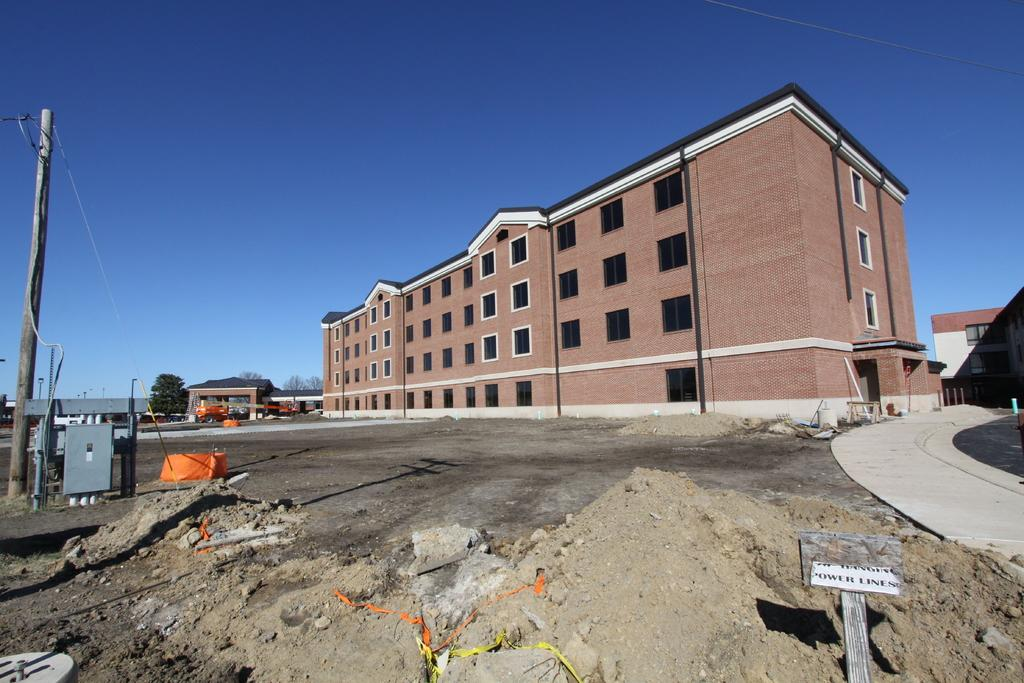What type of structure is present in the image? There is a building in the image. Are there any residential structures in the image? Yes, there are houses in the image. What else can be seen in the image besides buildings and houses? There are poles and trees in the image. What is visible in the background of the image? The sky is visible in the background of the image. Can you see a woman walking her dog at night in the image? There is no woman or dog present in the image, and the time of day is not specified. 